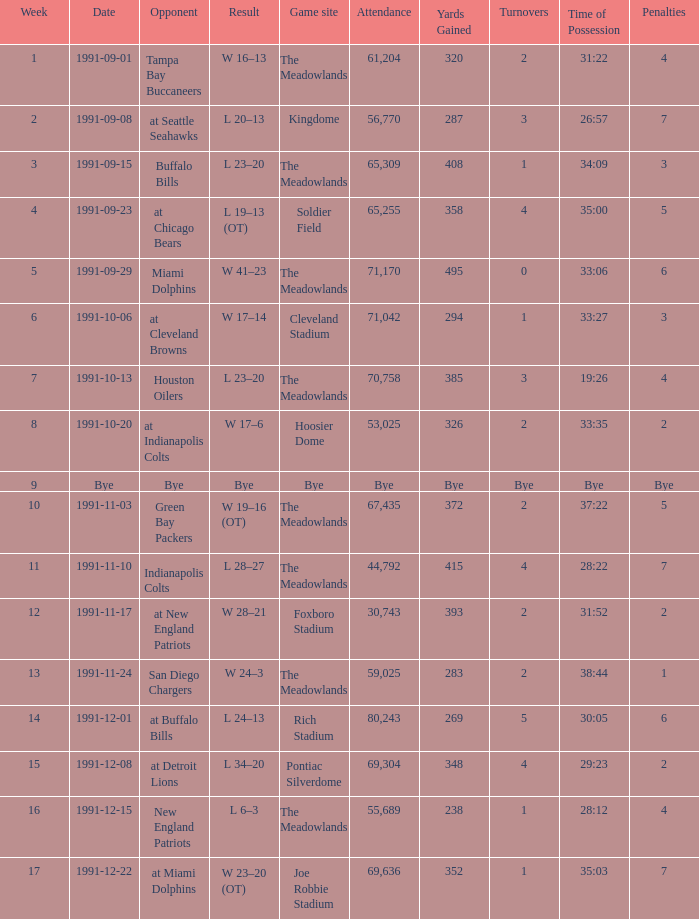What was the Result of the Game at the Meadowlands on 1991-09-01? W 16–13. 